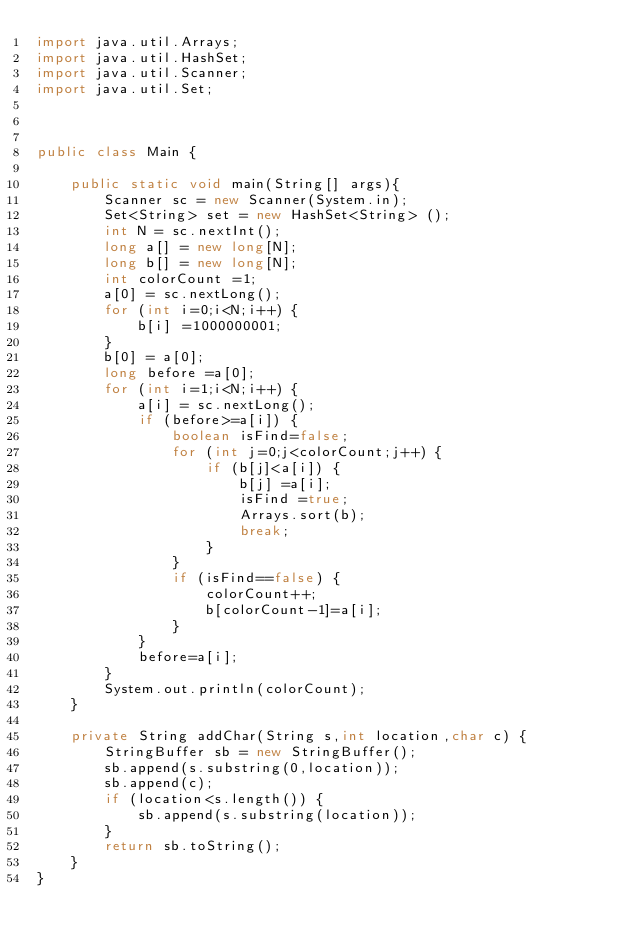Convert code to text. <code><loc_0><loc_0><loc_500><loc_500><_Java_>import java.util.Arrays;
import java.util.HashSet;
import java.util.Scanner;
import java.util.Set;



public class Main {

	public static void main(String[] args){
		Scanner sc = new Scanner(System.in);
		Set<String> set = new HashSet<String> ();
		int N = sc.nextInt();
		long a[] = new long[N];
		long b[] = new long[N];
		int colorCount =1;
		a[0] = sc.nextLong();
		for (int i=0;i<N;i++) {
			b[i] =1000000001;
		}
		b[0] = a[0];
		long before =a[0];
		for (int i=1;i<N;i++) {
			a[i] = sc.nextLong();
			if (before>=a[i]) {
				boolean isFind=false;
				for (int j=0;j<colorCount;j++) {
					if (b[j]<a[i]) {
						b[j] =a[i];
						isFind =true;
						Arrays.sort(b);
						break;
					}
				}
				if (isFind==false) {
					colorCount++;
					b[colorCount-1]=a[i];
				}
			}
			before=a[i];
		}
		System.out.println(colorCount);
  	}

	private String addChar(String s,int location,char c) {
		StringBuffer sb = new StringBuffer();
		sb.append(s.substring(0,location));
		sb.append(c);
		if (location<s.length()) {
			sb.append(s.substring(location));
		}
		return sb.toString();
	}
}</code> 